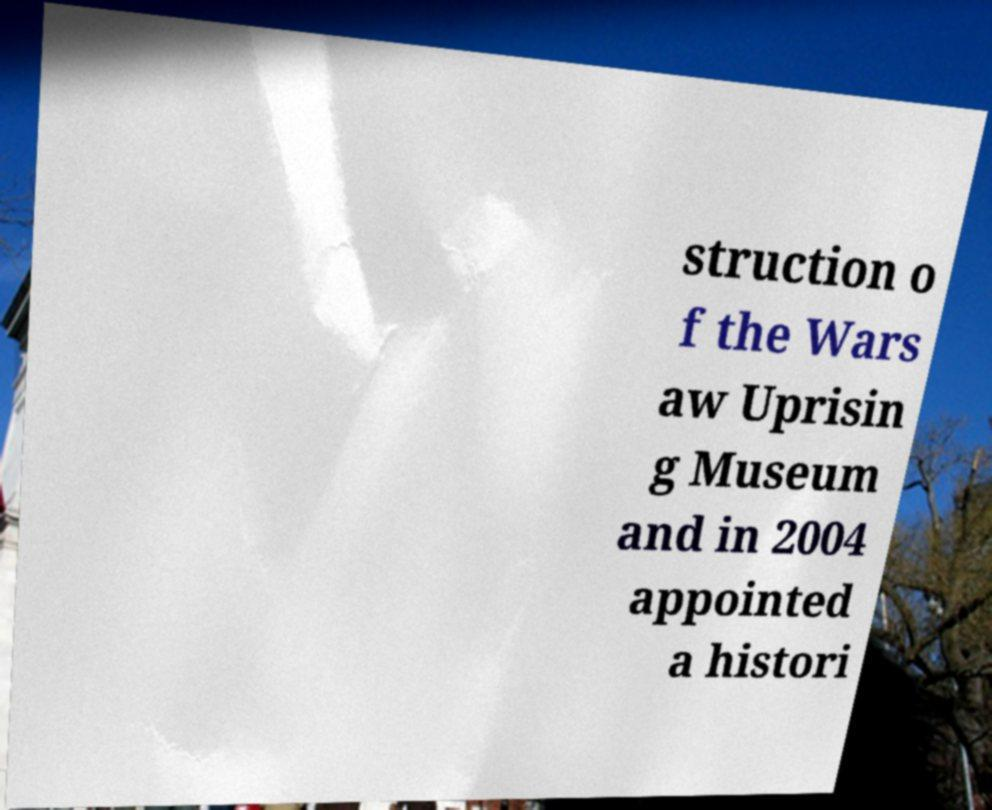Please identify and transcribe the text found in this image. struction o f the Wars aw Uprisin g Museum and in 2004 appointed a histori 